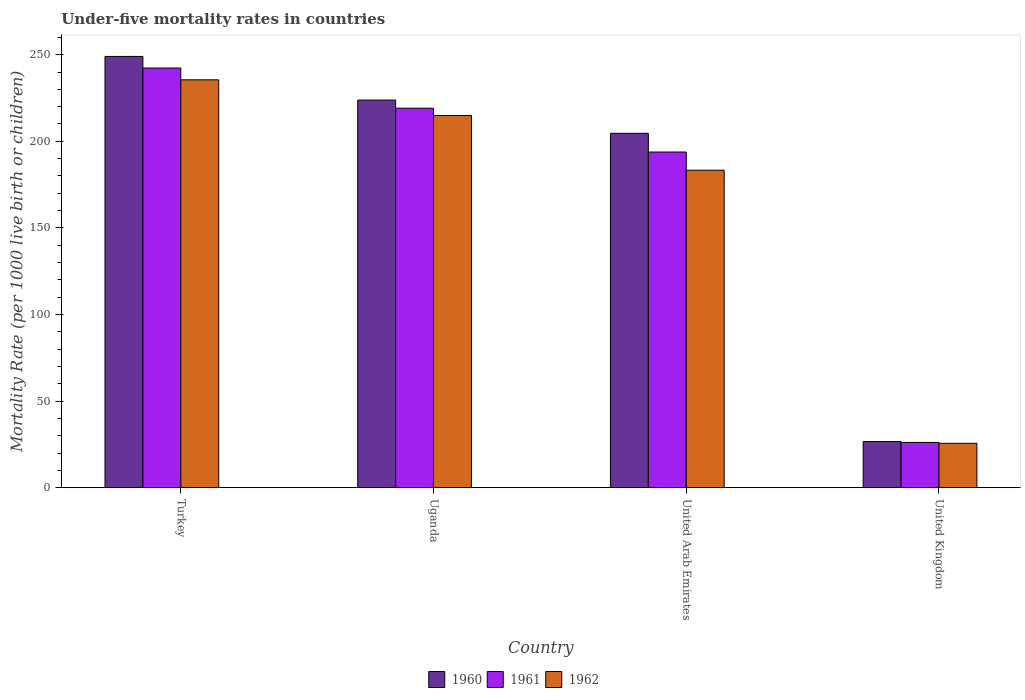How many different coloured bars are there?
Offer a very short reply. 3. How many groups of bars are there?
Your answer should be compact. 4. Are the number of bars per tick equal to the number of legend labels?
Make the answer very short. Yes. How many bars are there on the 2nd tick from the right?
Your response must be concise. 3. What is the label of the 1st group of bars from the left?
Offer a terse response. Turkey. In how many cases, is the number of bars for a given country not equal to the number of legend labels?
Keep it short and to the point. 0. What is the under-five mortality rate in 1961 in United Kingdom?
Give a very brief answer. 26.1. Across all countries, what is the maximum under-five mortality rate in 1961?
Ensure brevity in your answer.  242.3. Across all countries, what is the minimum under-five mortality rate in 1961?
Ensure brevity in your answer.  26.1. In which country was the under-five mortality rate in 1961 maximum?
Keep it short and to the point. Turkey. What is the total under-five mortality rate in 1961 in the graph?
Offer a terse response. 681.3. What is the difference between the under-five mortality rate in 1961 in Uganda and that in United Kingdom?
Your response must be concise. 193. What is the difference between the under-five mortality rate in 1962 in Turkey and the under-five mortality rate in 1961 in United Arab Emirates?
Give a very brief answer. 41.7. What is the average under-five mortality rate in 1960 per country?
Your response must be concise. 176. What is the difference between the under-five mortality rate of/in 1960 and under-five mortality rate of/in 1961 in United Kingdom?
Give a very brief answer. 0.5. What is the ratio of the under-five mortality rate in 1962 in United Arab Emirates to that in United Kingdom?
Offer a terse response. 7.16. Is the under-five mortality rate in 1962 in United Arab Emirates less than that in United Kingdom?
Give a very brief answer. No. Is the difference between the under-five mortality rate in 1960 in Turkey and United Arab Emirates greater than the difference between the under-five mortality rate in 1961 in Turkey and United Arab Emirates?
Provide a short and direct response. No. What is the difference between the highest and the second highest under-five mortality rate in 1960?
Provide a short and direct response. 44.4. What is the difference between the highest and the lowest under-five mortality rate in 1962?
Make the answer very short. 209.9. In how many countries, is the under-five mortality rate in 1960 greater than the average under-five mortality rate in 1960 taken over all countries?
Provide a succinct answer. 3. What does the 2nd bar from the left in Turkey represents?
Ensure brevity in your answer.  1961. Is it the case that in every country, the sum of the under-five mortality rate in 1962 and under-five mortality rate in 1961 is greater than the under-five mortality rate in 1960?
Offer a very short reply. Yes. How many bars are there?
Provide a short and direct response. 12. How many countries are there in the graph?
Offer a very short reply. 4. Does the graph contain any zero values?
Keep it short and to the point. No. Does the graph contain grids?
Provide a short and direct response. No. Where does the legend appear in the graph?
Your response must be concise. Bottom center. What is the title of the graph?
Keep it short and to the point. Under-five mortality rates in countries. What is the label or title of the X-axis?
Provide a succinct answer. Country. What is the label or title of the Y-axis?
Keep it short and to the point. Mortality Rate (per 1000 live birth or children). What is the Mortality Rate (per 1000 live birth or children) of 1960 in Turkey?
Ensure brevity in your answer.  249. What is the Mortality Rate (per 1000 live birth or children) in 1961 in Turkey?
Make the answer very short. 242.3. What is the Mortality Rate (per 1000 live birth or children) in 1962 in Turkey?
Provide a succinct answer. 235.5. What is the Mortality Rate (per 1000 live birth or children) of 1960 in Uganda?
Make the answer very short. 223.8. What is the Mortality Rate (per 1000 live birth or children) in 1961 in Uganda?
Your response must be concise. 219.1. What is the Mortality Rate (per 1000 live birth or children) in 1962 in Uganda?
Provide a succinct answer. 214.9. What is the Mortality Rate (per 1000 live birth or children) of 1960 in United Arab Emirates?
Offer a terse response. 204.6. What is the Mortality Rate (per 1000 live birth or children) of 1961 in United Arab Emirates?
Ensure brevity in your answer.  193.8. What is the Mortality Rate (per 1000 live birth or children) in 1962 in United Arab Emirates?
Your response must be concise. 183.3. What is the Mortality Rate (per 1000 live birth or children) of 1960 in United Kingdom?
Your response must be concise. 26.6. What is the Mortality Rate (per 1000 live birth or children) of 1961 in United Kingdom?
Offer a very short reply. 26.1. What is the Mortality Rate (per 1000 live birth or children) of 1962 in United Kingdom?
Provide a succinct answer. 25.6. Across all countries, what is the maximum Mortality Rate (per 1000 live birth or children) in 1960?
Provide a succinct answer. 249. Across all countries, what is the maximum Mortality Rate (per 1000 live birth or children) in 1961?
Ensure brevity in your answer.  242.3. Across all countries, what is the maximum Mortality Rate (per 1000 live birth or children) of 1962?
Provide a succinct answer. 235.5. Across all countries, what is the minimum Mortality Rate (per 1000 live birth or children) of 1960?
Provide a succinct answer. 26.6. Across all countries, what is the minimum Mortality Rate (per 1000 live birth or children) of 1961?
Your answer should be very brief. 26.1. Across all countries, what is the minimum Mortality Rate (per 1000 live birth or children) of 1962?
Make the answer very short. 25.6. What is the total Mortality Rate (per 1000 live birth or children) in 1960 in the graph?
Offer a terse response. 704. What is the total Mortality Rate (per 1000 live birth or children) in 1961 in the graph?
Your answer should be compact. 681.3. What is the total Mortality Rate (per 1000 live birth or children) of 1962 in the graph?
Keep it short and to the point. 659.3. What is the difference between the Mortality Rate (per 1000 live birth or children) in 1960 in Turkey and that in Uganda?
Keep it short and to the point. 25.2. What is the difference between the Mortality Rate (per 1000 live birth or children) in 1961 in Turkey and that in Uganda?
Your response must be concise. 23.2. What is the difference between the Mortality Rate (per 1000 live birth or children) of 1962 in Turkey and that in Uganda?
Offer a very short reply. 20.6. What is the difference between the Mortality Rate (per 1000 live birth or children) in 1960 in Turkey and that in United Arab Emirates?
Provide a succinct answer. 44.4. What is the difference between the Mortality Rate (per 1000 live birth or children) of 1961 in Turkey and that in United Arab Emirates?
Your answer should be compact. 48.5. What is the difference between the Mortality Rate (per 1000 live birth or children) in 1962 in Turkey and that in United Arab Emirates?
Make the answer very short. 52.2. What is the difference between the Mortality Rate (per 1000 live birth or children) in 1960 in Turkey and that in United Kingdom?
Ensure brevity in your answer.  222.4. What is the difference between the Mortality Rate (per 1000 live birth or children) of 1961 in Turkey and that in United Kingdom?
Ensure brevity in your answer.  216.2. What is the difference between the Mortality Rate (per 1000 live birth or children) of 1962 in Turkey and that in United Kingdom?
Give a very brief answer. 209.9. What is the difference between the Mortality Rate (per 1000 live birth or children) in 1961 in Uganda and that in United Arab Emirates?
Your answer should be very brief. 25.3. What is the difference between the Mortality Rate (per 1000 live birth or children) of 1962 in Uganda and that in United Arab Emirates?
Keep it short and to the point. 31.6. What is the difference between the Mortality Rate (per 1000 live birth or children) in 1960 in Uganda and that in United Kingdom?
Offer a terse response. 197.2. What is the difference between the Mortality Rate (per 1000 live birth or children) in 1961 in Uganda and that in United Kingdom?
Ensure brevity in your answer.  193. What is the difference between the Mortality Rate (per 1000 live birth or children) in 1962 in Uganda and that in United Kingdom?
Your answer should be very brief. 189.3. What is the difference between the Mortality Rate (per 1000 live birth or children) of 1960 in United Arab Emirates and that in United Kingdom?
Make the answer very short. 178. What is the difference between the Mortality Rate (per 1000 live birth or children) of 1961 in United Arab Emirates and that in United Kingdom?
Keep it short and to the point. 167.7. What is the difference between the Mortality Rate (per 1000 live birth or children) of 1962 in United Arab Emirates and that in United Kingdom?
Provide a succinct answer. 157.7. What is the difference between the Mortality Rate (per 1000 live birth or children) of 1960 in Turkey and the Mortality Rate (per 1000 live birth or children) of 1961 in Uganda?
Your response must be concise. 29.9. What is the difference between the Mortality Rate (per 1000 live birth or children) in 1960 in Turkey and the Mortality Rate (per 1000 live birth or children) in 1962 in Uganda?
Your answer should be compact. 34.1. What is the difference between the Mortality Rate (per 1000 live birth or children) of 1961 in Turkey and the Mortality Rate (per 1000 live birth or children) of 1962 in Uganda?
Provide a short and direct response. 27.4. What is the difference between the Mortality Rate (per 1000 live birth or children) of 1960 in Turkey and the Mortality Rate (per 1000 live birth or children) of 1961 in United Arab Emirates?
Offer a very short reply. 55.2. What is the difference between the Mortality Rate (per 1000 live birth or children) in 1960 in Turkey and the Mortality Rate (per 1000 live birth or children) in 1962 in United Arab Emirates?
Your answer should be compact. 65.7. What is the difference between the Mortality Rate (per 1000 live birth or children) of 1961 in Turkey and the Mortality Rate (per 1000 live birth or children) of 1962 in United Arab Emirates?
Make the answer very short. 59. What is the difference between the Mortality Rate (per 1000 live birth or children) in 1960 in Turkey and the Mortality Rate (per 1000 live birth or children) in 1961 in United Kingdom?
Offer a very short reply. 222.9. What is the difference between the Mortality Rate (per 1000 live birth or children) in 1960 in Turkey and the Mortality Rate (per 1000 live birth or children) in 1962 in United Kingdom?
Your answer should be compact. 223.4. What is the difference between the Mortality Rate (per 1000 live birth or children) in 1961 in Turkey and the Mortality Rate (per 1000 live birth or children) in 1962 in United Kingdom?
Your response must be concise. 216.7. What is the difference between the Mortality Rate (per 1000 live birth or children) of 1960 in Uganda and the Mortality Rate (per 1000 live birth or children) of 1961 in United Arab Emirates?
Offer a terse response. 30. What is the difference between the Mortality Rate (per 1000 live birth or children) of 1960 in Uganda and the Mortality Rate (per 1000 live birth or children) of 1962 in United Arab Emirates?
Provide a short and direct response. 40.5. What is the difference between the Mortality Rate (per 1000 live birth or children) in 1961 in Uganda and the Mortality Rate (per 1000 live birth or children) in 1962 in United Arab Emirates?
Make the answer very short. 35.8. What is the difference between the Mortality Rate (per 1000 live birth or children) in 1960 in Uganda and the Mortality Rate (per 1000 live birth or children) in 1961 in United Kingdom?
Provide a succinct answer. 197.7. What is the difference between the Mortality Rate (per 1000 live birth or children) in 1960 in Uganda and the Mortality Rate (per 1000 live birth or children) in 1962 in United Kingdom?
Offer a very short reply. 198.2. What is the difference between the Mortality Rate (per 1000 live birth or children) in 1961 in Uganda and the Mortality Rate (per 1000 live birth or children) in 1962 in United Kingdom?
Give a very brief answer. 193.5. What is the difference between the Mortality Rate (per 1000 live birth or children) in 1960 in United Arab Emirates and the Mortality Rate (per 1000 live birth or children) in 1961 in United Kingdom?
Your answer should be compact. 178.5. What is the difference between the Mortality Rate (per 1000 live birth or children) in 1960 in United Arab Emirates and the Mortality Rate (per 1000 live birth or children) in 1962 in United Kingdom?
Ensure brevity in your answer.  179. What is the difference between the Mortality Rate (per 1000 live birth or children) in 1961 in United Arab Emirates and the Mortality Rate (per 1000 live birth or children) in 1962 in United Kingdom?
Offer a very short reply. 168.2. What is the average Mortality Rate (per 1000 live birth or children) of 1960 per country?
Ensure brevity in your answer.  176. What is the average Mortality Rate (per 1000 live birth or children) of 1961 per country?
Provide a short and direct response. 170.32. What is the average Mortality Rate (per 1000 live birth or children) of 1962 per country?
Provide a succinct answer. 164.82. What is the difference between the Mortality Rate (per 1000 live birth or children) of 1960 and Mortality Rate (per 1000 live birth or children) of 1962 in Turkey?
Your response must be concise. 13.5. What is the difference between the Mortality Rate (per 1000 live birth or children) in 1961 and Mortality Rate (per 1000 live birth or children) in 1962 in Turkey?
Provide a short and direct response. 6.8. What is the difference between the Mortality Rate (per 1000 live birth or children) in 1960 and Mortality Rate (per 1000 live birth or children) in 1962 in Uganda?
Your response must be concise. 8.9. What is the difference between the Mortality Rate (per 1000 live birth or children) of 1961 and Mortality Rate (per 1000 live birth or children) of 1962 in Uganda?
Keep it short and to the point. 4.2. What is the difference between the Mortality Rate (per 1000 live birth or children) in 1960 and Mortality Rate (per 1000 live birth or children) in 1962 in United Arab Emirates?
Make the answer very short. 21.3. What is the difference between the Mortality Rate (per 1000 live birth or children) in 1960 and Mortality Rate (per 1000 live birth or children) in 1961 in United Kingdom?
Your answer should be very brief. 0.5. What is the difference between the Mortality Rate (per 1000 live birth or children) of 1961 and Mortality Rate (per 1000 live birth or children) of 1962 in United Kingdom?
Offer a terse response. 0.5. What is the ratio of the Mortality Rate (per 1000 live birth or children) in 1960 in Turkey to that in Uganda?
Give a very brief answer. 1.11. What is the ratio of the Mortality Rate (per 1000 live birth or children) in 1961 in Turkey to that in Uganda?
Ensure brevity in your answer.  1.11. What is the ratio of the Mortality Rate (per 1000 live birth or children) of 1962 in Turkey to that in Uganda?
Offer a terse response. 1.1. What is the ratio of the Mortality Rate (per 1000 live birth or children) in 1960 in Turkey to that in United Arab Emirates?
Your response must be concise. 1.22. What is the ratio of the Mortality Rate (per 1000 live birth or children) in 1961 in Turkey to that in United Arab Emirates?
Provide a succinct answer. 1.25. What is the ratio of the Mortality Rate (per 1000 live birth or children) in 1962 in Turkey to that in United Arab Emirates?
Offer a very short reply. 1.28. What is the ratio of the Mortality Rate (per 1000 live birth or children) of 1960 in Turkey to that in United Kingdom?
Keep it short and to the point. 9.36. What is the ratio of the Mortality Rate (per 1000 live birth or children) in 1961 in Turkey to that in United Kingdom?
Your response must be concise. 9.28. What is the ratio of the Mortality Rate (per 1000 live birth or children) of 1962 in Turkey to that in United Kingdom?
Provide a short and direct response. 9.2. What is the ratio of the Mortality Rate (per 1000 live birth or children) in 1960 in Uganda to that in United Arab Emirates?
Offer a terse response. 1.09. What is the ratio of the Mortality Rate (per 1000 live birth or children) of 1961 in Uganda to that in United Arab Emirates?
Keep it short and to the point. 1.13. What is the ratio of the Mortality Rate (per 1000 live birth or children) of 1962 in Uganda to that in United Arab Emirates?
Provide a succinct answer. 1.17. What is the ratio of the Mortality Rate (per 1000 live birth or children) of 1960 in Uganda to that in United Kingdom?
Your response must be concise. 8.41. What is the ratio of the Mortality Rate (per 1000 live birth or children) of 1961 in Uganda to that in United Kingdom?
Make the answer very short. 8.39. What is the ratio of the Mortality Rate (per 1000 live birth or children) of 1962 in Uganda to that in United Kingdom?
Provide a short and direct response. 8.39. What is the ratio of the Mortality Rate (per 1000 live birth or children) of 1960 in United Arab Emirates to that in United Kingdom?
Offer a terse response. 7.69. What is the ratio of the Mortality Rate (per 1000 live birth or children) in 1961 in United Arab Emirates to that in United Kingdom?
Offer a terse response. 7.43. What is the ratio of the Mortality Rate (per 1000 live birth or children) of 1962 in United Arab Emirates to that in United Kingdom?
Your answer should be compact. 7.16. What is the difference between the highest and the second highest Mortality Rate (per 1000 live birth or children) of 1960?
Keep it short and to the point. 25.2. What is the difference between the highest and the second highest Mortality Rate (per 1000 live birth or children) in 1961?
Provide a short and direct response. 23.2. What is the difference between the highest and the second highest Mortality Rate (per 1000 live birth or children) of 1962?
Make the answer very short. 20.6. What is the difference between the highest and the lowest Mortality Rate (per 1000 live birth or children) in 1960?
Give a very brief answer. 222.4. What is the difference between the highest and the lowest Mortality Rate (per 1000 live birth or children) of 1961?
Keep it short and to the point. 216.2. What is the difference between the highest and the lowest Mortality Rate (per 1000 live birth or children) in 1962?
Offer a very short reply. 209.9. 